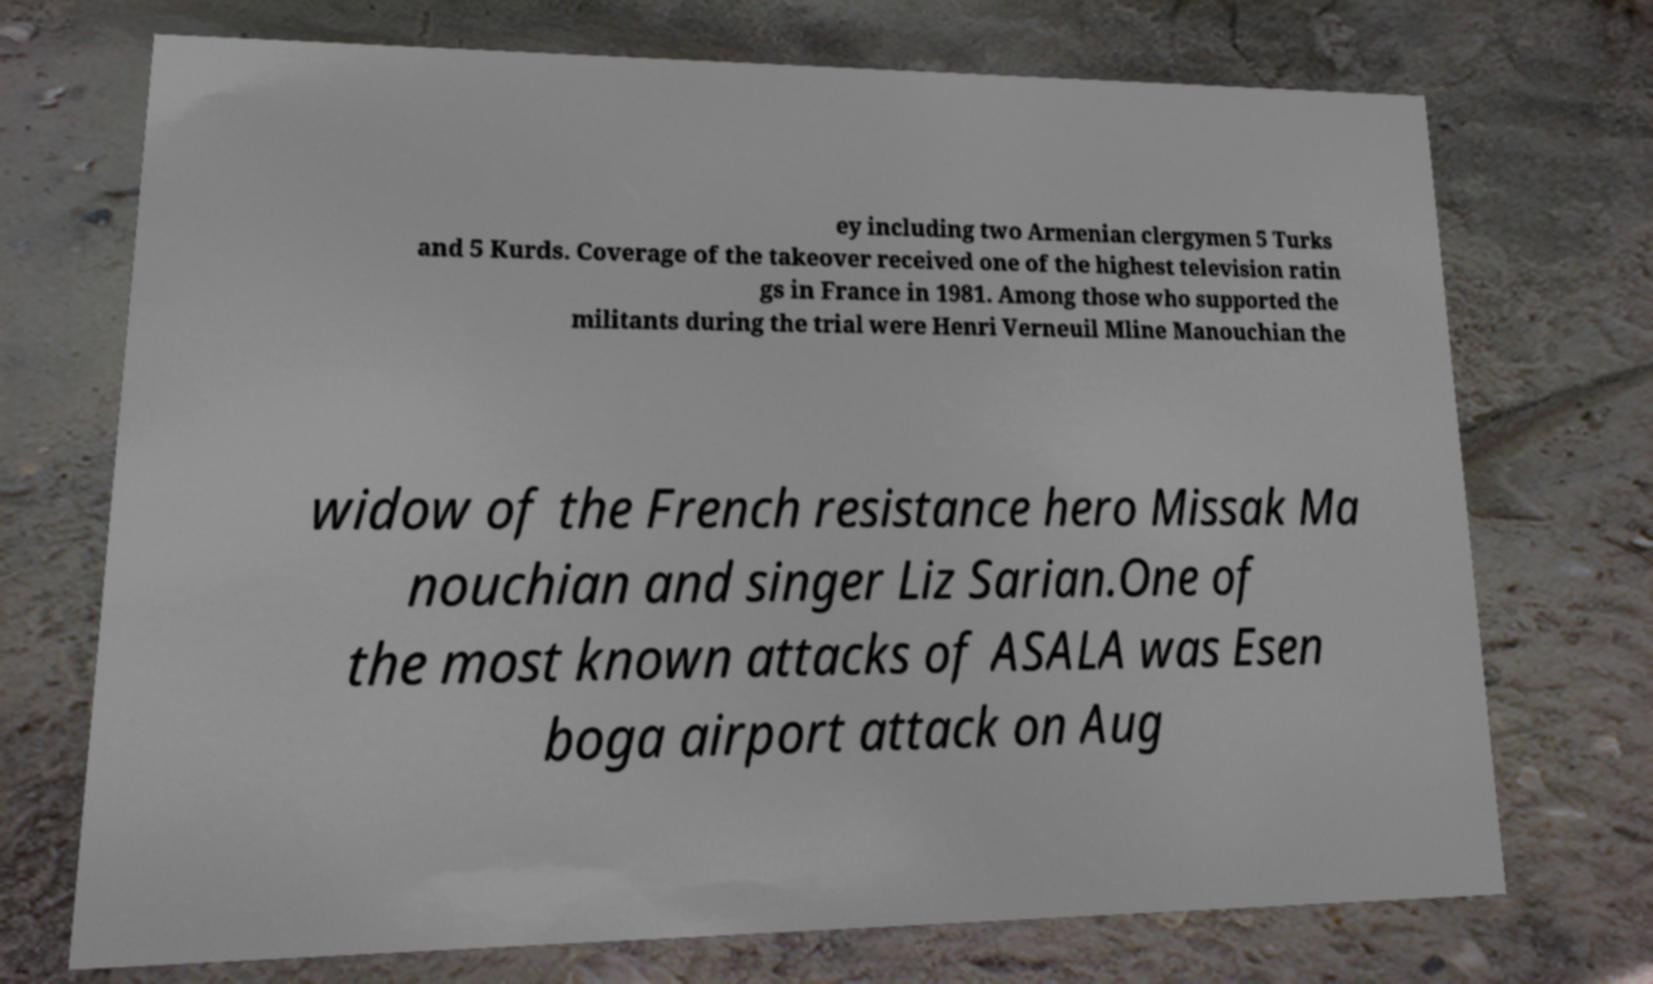Could you assist in decoding the text presented in this image and type it out clearly? ey including two Armenian clergymen 5 Turks and 5 Kurds. Coverage of the takeover received one of the highest television ratin gs in France in 1981. Among those who supported the militants during the trial were Henri Verneuil Mline Manouchian the widow of the French resistance hero Missak Ma nouchian and singer Liz Sarian.One of the most known attacks of ASALA was Esen boga airport attack on Aug 